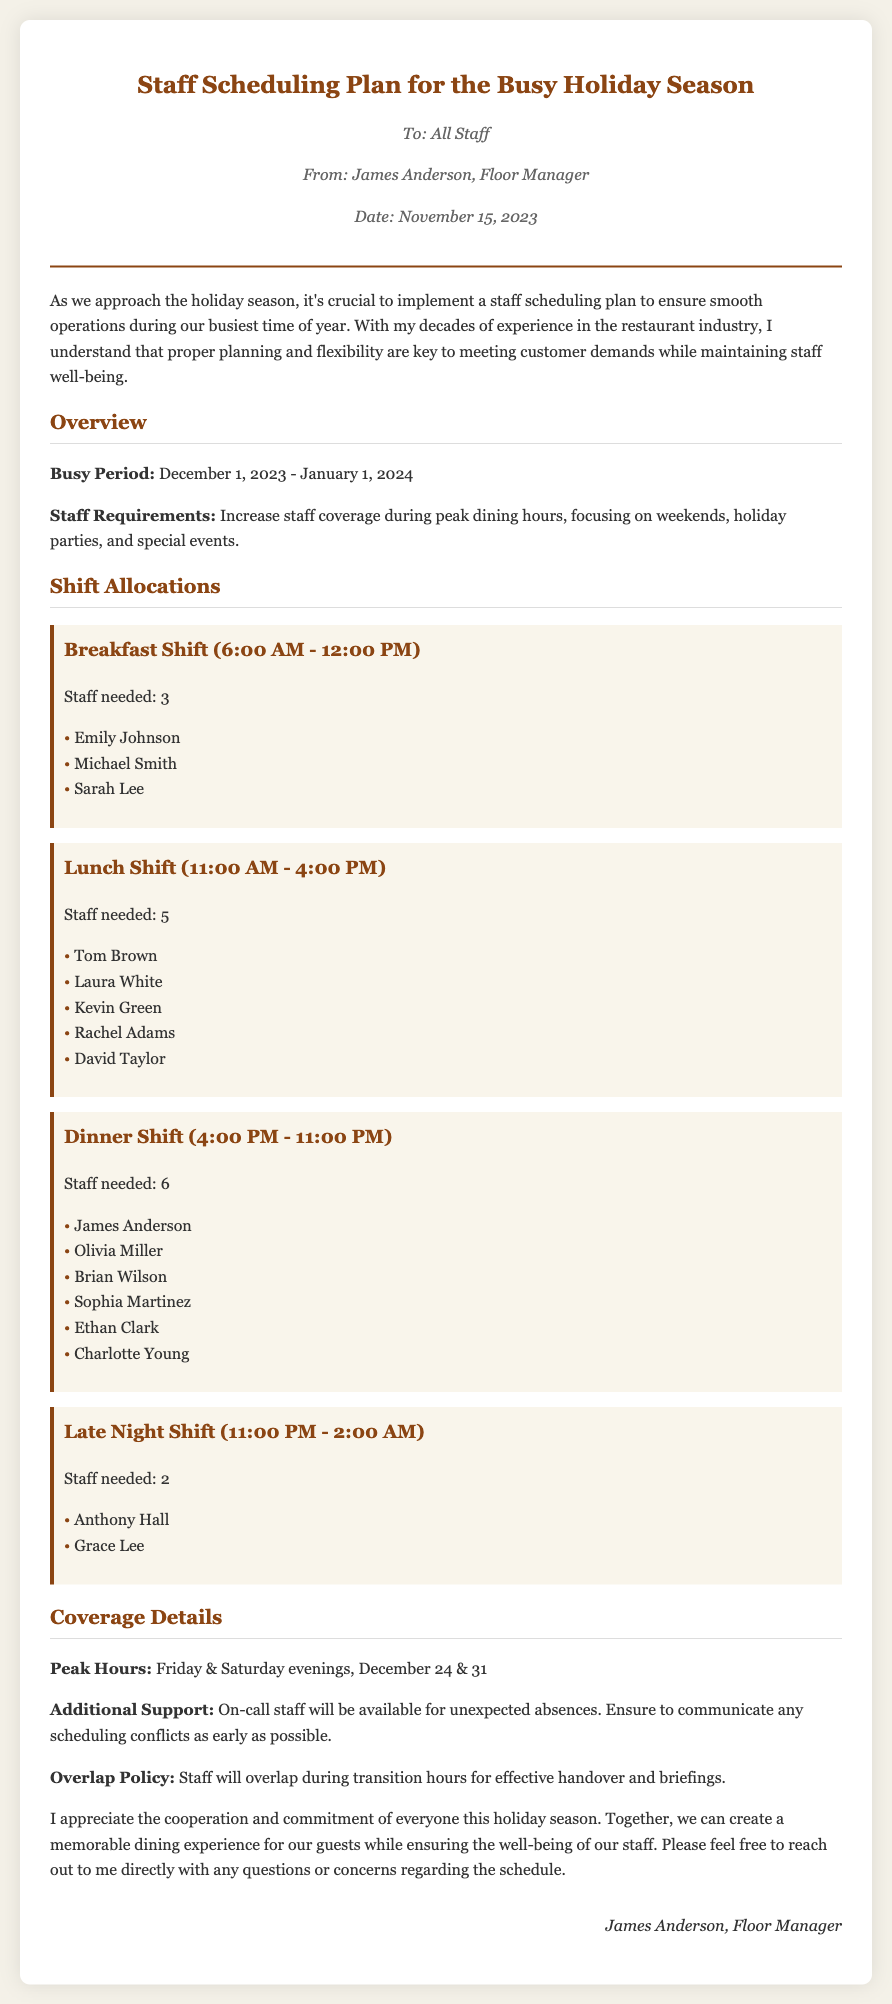What is the duration of the busy period? The busy period is specified in the document as lasting from December 1, 2023, to January 1, 2024.
Answer: December 1, 2023 - January 1, 2024 How many staff are needed for the lunch shift? The document states the number of staff needed for the lunch shift, which is clearly mentioned in the shift allocation section.
Answer: 5 Who is responsible for the dinner shift? The document lists the names of the staff assigned to the dinner shift, providing specific individuals for that timeframe.
Answer: James Anderson, Olivia Miller, Brian Wilson, Sophia Martinez, Ethan Clark, Charlotte Young What is the overlap policy mentioned in the memo? The overlap policy is outlined in the coverage details section of the document regarding staff transitioning between shifts.
Answer: Staff will overlap during transition hours What dates are specified as peak hours? The memo highlights specific dates when peak hours occur, which are explicitly stated in the coverage details section.
Answer: December 24 & 31 Name one person assigned to the breakfast shift. The document lists three individuals assigned to the breakfast shift, specified under the breakfast shift allocation.
Answer: Emily Johnson What is the staff required for the late night shift? The document provides details about staff allocations, specifically stating the number of staff needed for each shift in the shift allocations section.
Answer: 2 Who is the author of the memo? The author of the memo is mentioned in the header section, providing the name of the individual responsible for the communication.
Answer: James Anderson 